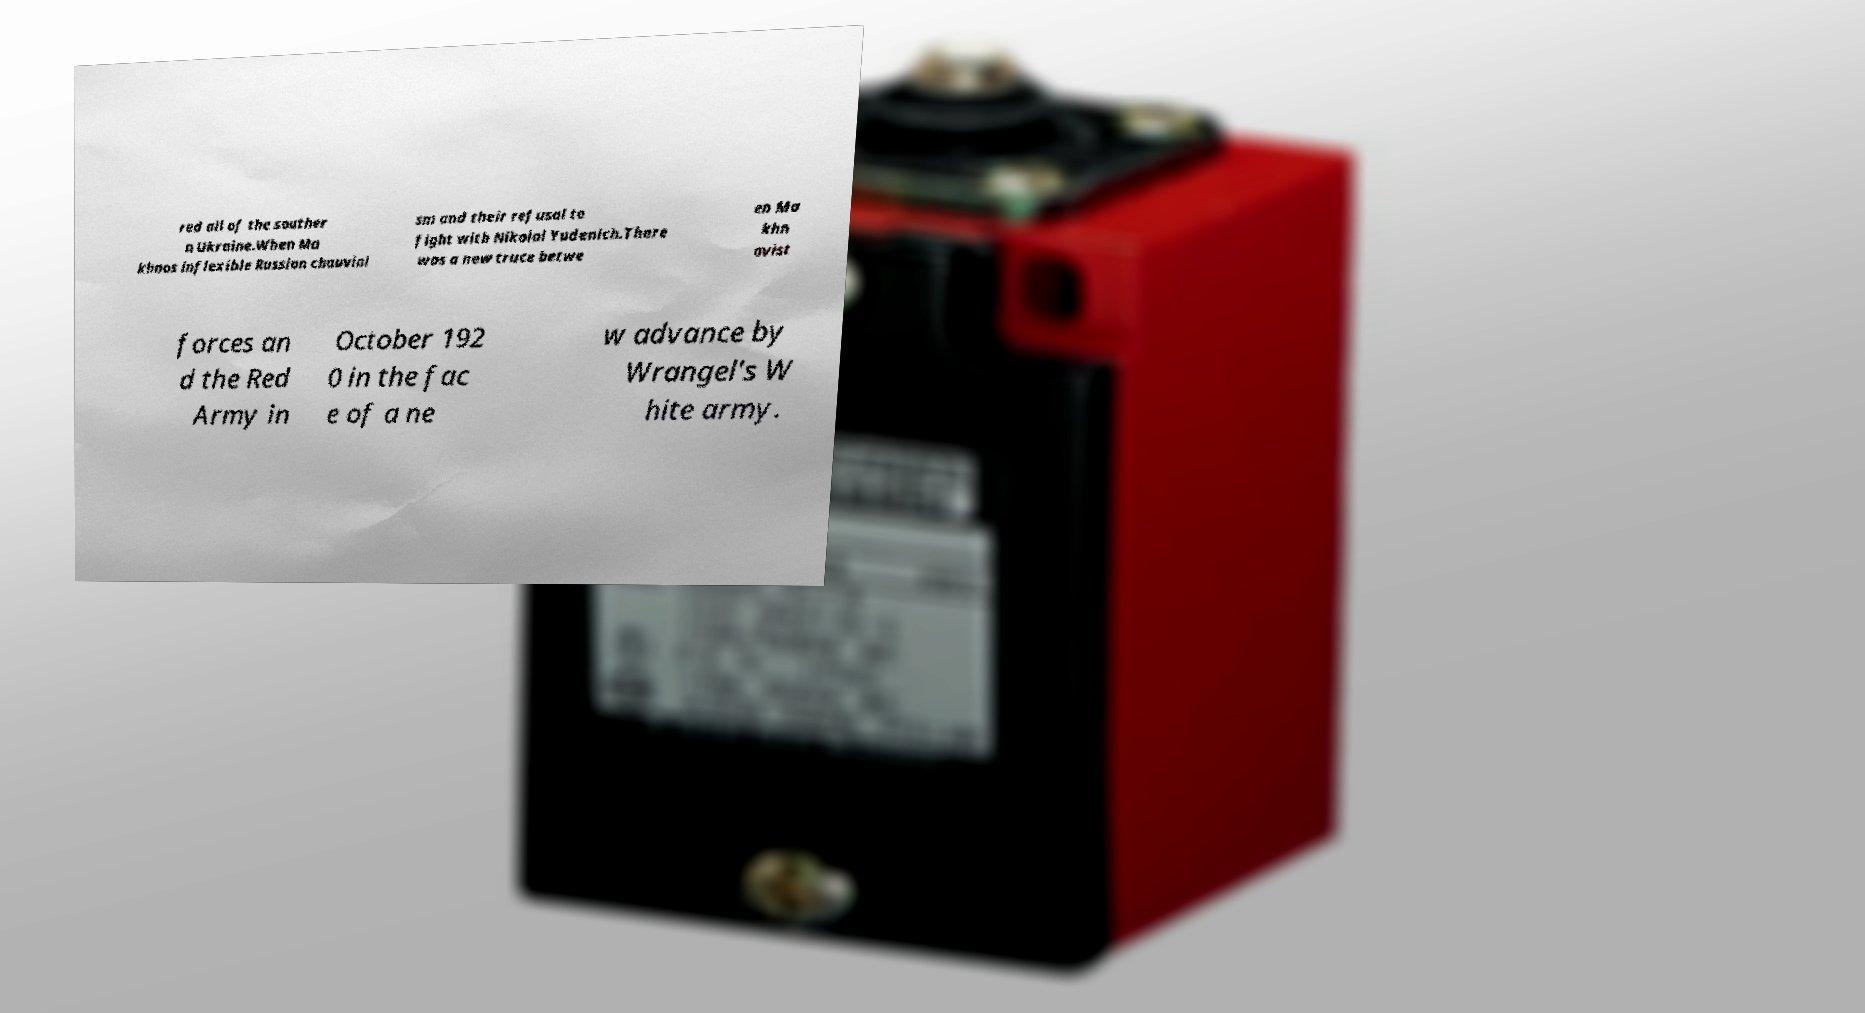Can you read and provide the text displayed in the image?This photo seems to have some interesting text. Can you extract and type it out for me? red all of the souther n Ukraine.When Ma khnos inflexible Russian chauvini sm and their refusal to fight with Nikolai Yudenich.There was a new truce betwe en Ma khn ovist forces an d the Red Army in October 192 0 in the fac e of a ne w advance by Wrangel's W hite army. 